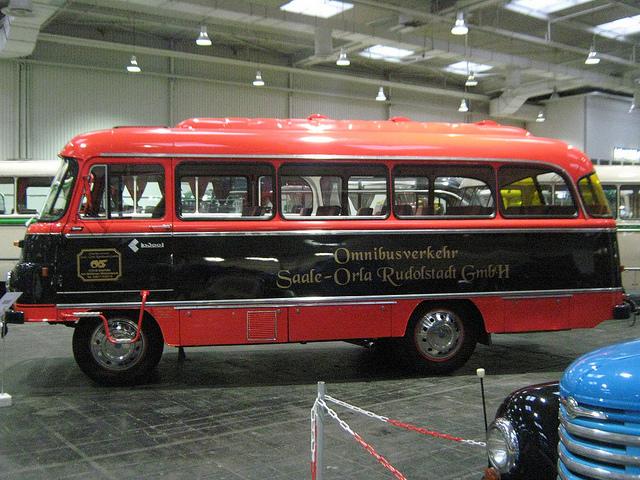What color is the vehicle?
Be succinct. Red and black. Are there any people inside this vehicle?
Answer briefly. No. Could this be a tour bus?
Answer briefly. Yes. 